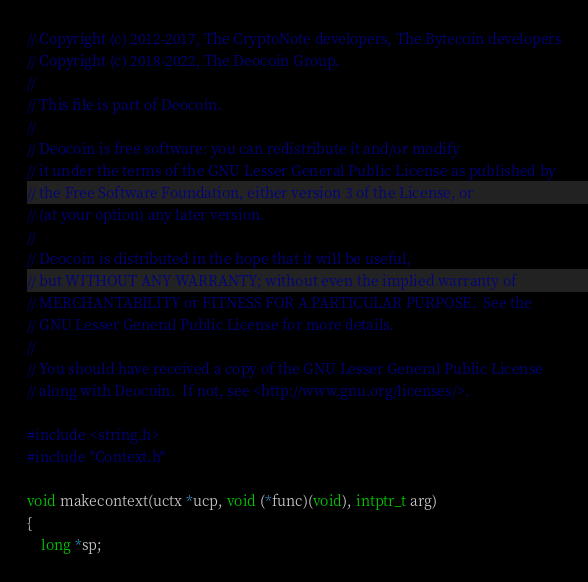<code> <loc_0><loc_0><loc_500><loc_500><_C_>// Copyright (c) 2012-2017, The CryptoNote developers, The Bytecoin developers
// Copyright (c) 2018-2022, The Deocoin Group.
//
// This file is part of Deocoin.
//
// Deocoin is free software: you can redistribute it and/or modify
// it under the terms of the GNU Lesser General Public License as published by
// the Free Software Foundation, either version 3 of the License, or
// (at your option) any later version.
//
// Deocoin is distributed in the hope that it will be useful,
// but WITHOUT ANY WARRANTY; without even the implied warranty of
// MERCHANTABILITY or FITNESS FOR A PARTICULAR PURPOSE.  See the
// GNU Lesser General Public License for more details.
//
// You should have received a copy of the GNU Lesser General Public License
// along with Deocoin.  If not, see <http://www.gnu.org/licenses/>.

#include <string.h>
#include "Context.h"

void makecontext(uctx *ucp, void (*func)(void), intptr_t arg)
{
    long *sp;
</code> 